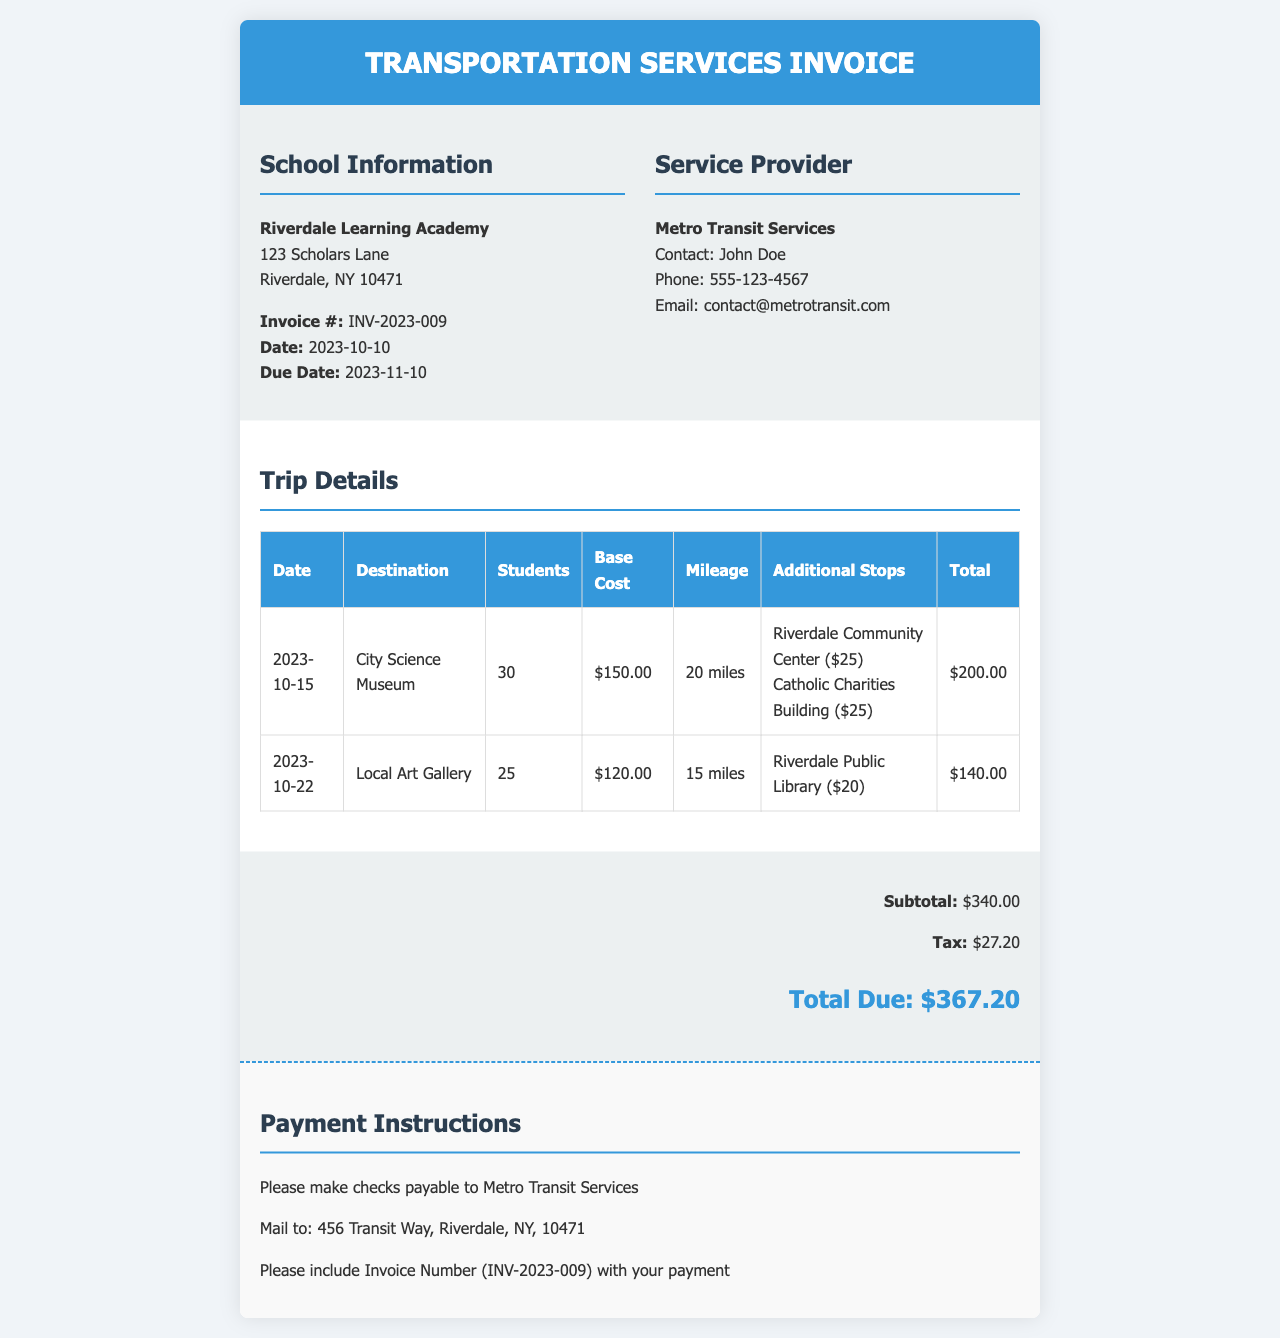What is the invoice number? The invoice number is a unique identifier for the invoice, found in the document.
Answer: INV-2023-009 What is the total due? The total due is the final amount that needs to be paid, calculated in the summary section.
Answer: $367.20 Who is the contact person for Metro Transit Services? The contact person is named in the service provider information section of the document.
Answer: John Doe How many students are attending the trip to the City Science Museum? This information is found in the trip details table under the respective trip row.
Answer: 30 What is the subtotal amount listed in the summary? The subtotal is the total of the base costs before adding taxes, found in the summary section.
Answer: $340.00 What is the tax amount calculated on the invoice? This amount is specified in the summary section of the document.
Answer: $27.20 Where should the payment checks be sent? The payment instructions section provides the mailing address for payments.
Answer: 456 Transit Way, Riverdale, NY, 10471 How many additional stops were made on the trip to the Local Art Gallery? The details about additional stops are listed in the trip details table for that specific trip.
Answer: 1 What is the base cost for the trip to the Local Art Gallery? The base cost is listed in the trip details table under the respective trip row.
Answer: $120.00 